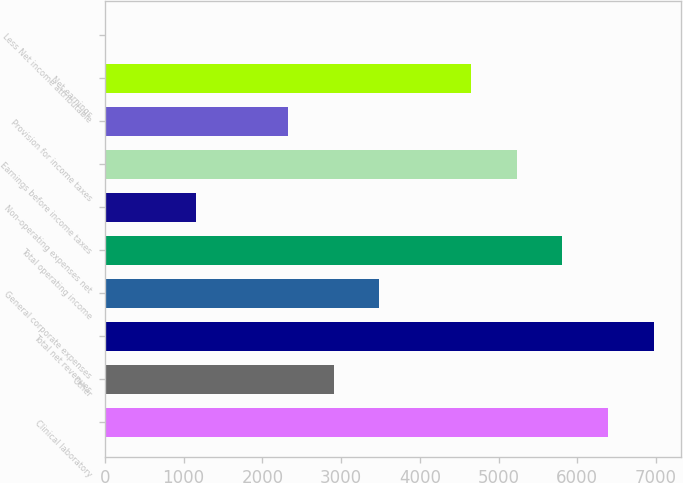<chart> <loc_0><loc_0><loc_500><loc_500><bar_chart><fcel>Clinical laboratory<fcel>Other<fcel>Total net revenues<fcel>General corporate expenses<fcel>Total operating income<fcel>Non-operating expenses net<fcel>Earnings before income taxes<fcel>Provision for income taxes<fcel>Net earnings<fcel>Less Net income attributable<nl><fcel>6388.97<fcel>2904.95<fcel>6969.64<fcel>3485.62<fcel>5808.3<fcel>1162.94<fcel>5227.63<fcel>2324.28<fcel>4646.96<fcel>1.6<nl></chart> 